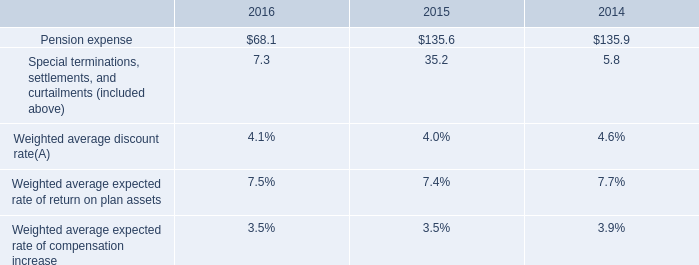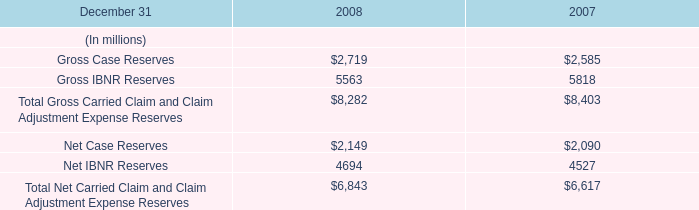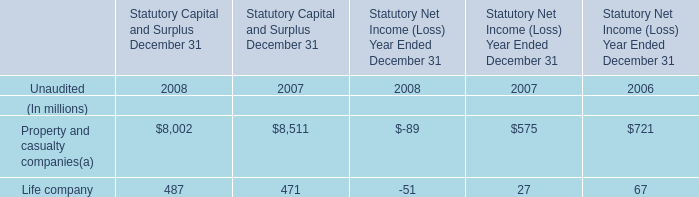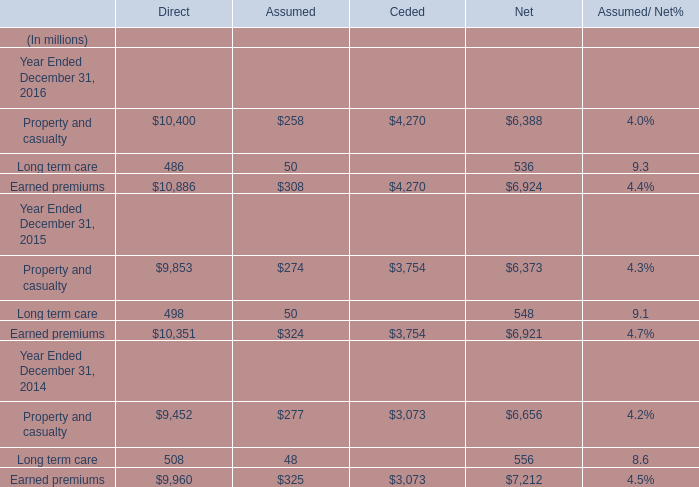What is the total amount of Earned premiums Year Ended December 31, 2015 of Ceded, Gross IBNR Reserves of 2008, and Property and casualty Year Ended December 31, 2015 of Ceded ? 
Computations: ((3754.0 + 5563.0) + 3754.0)
Answer: 13071.0. 